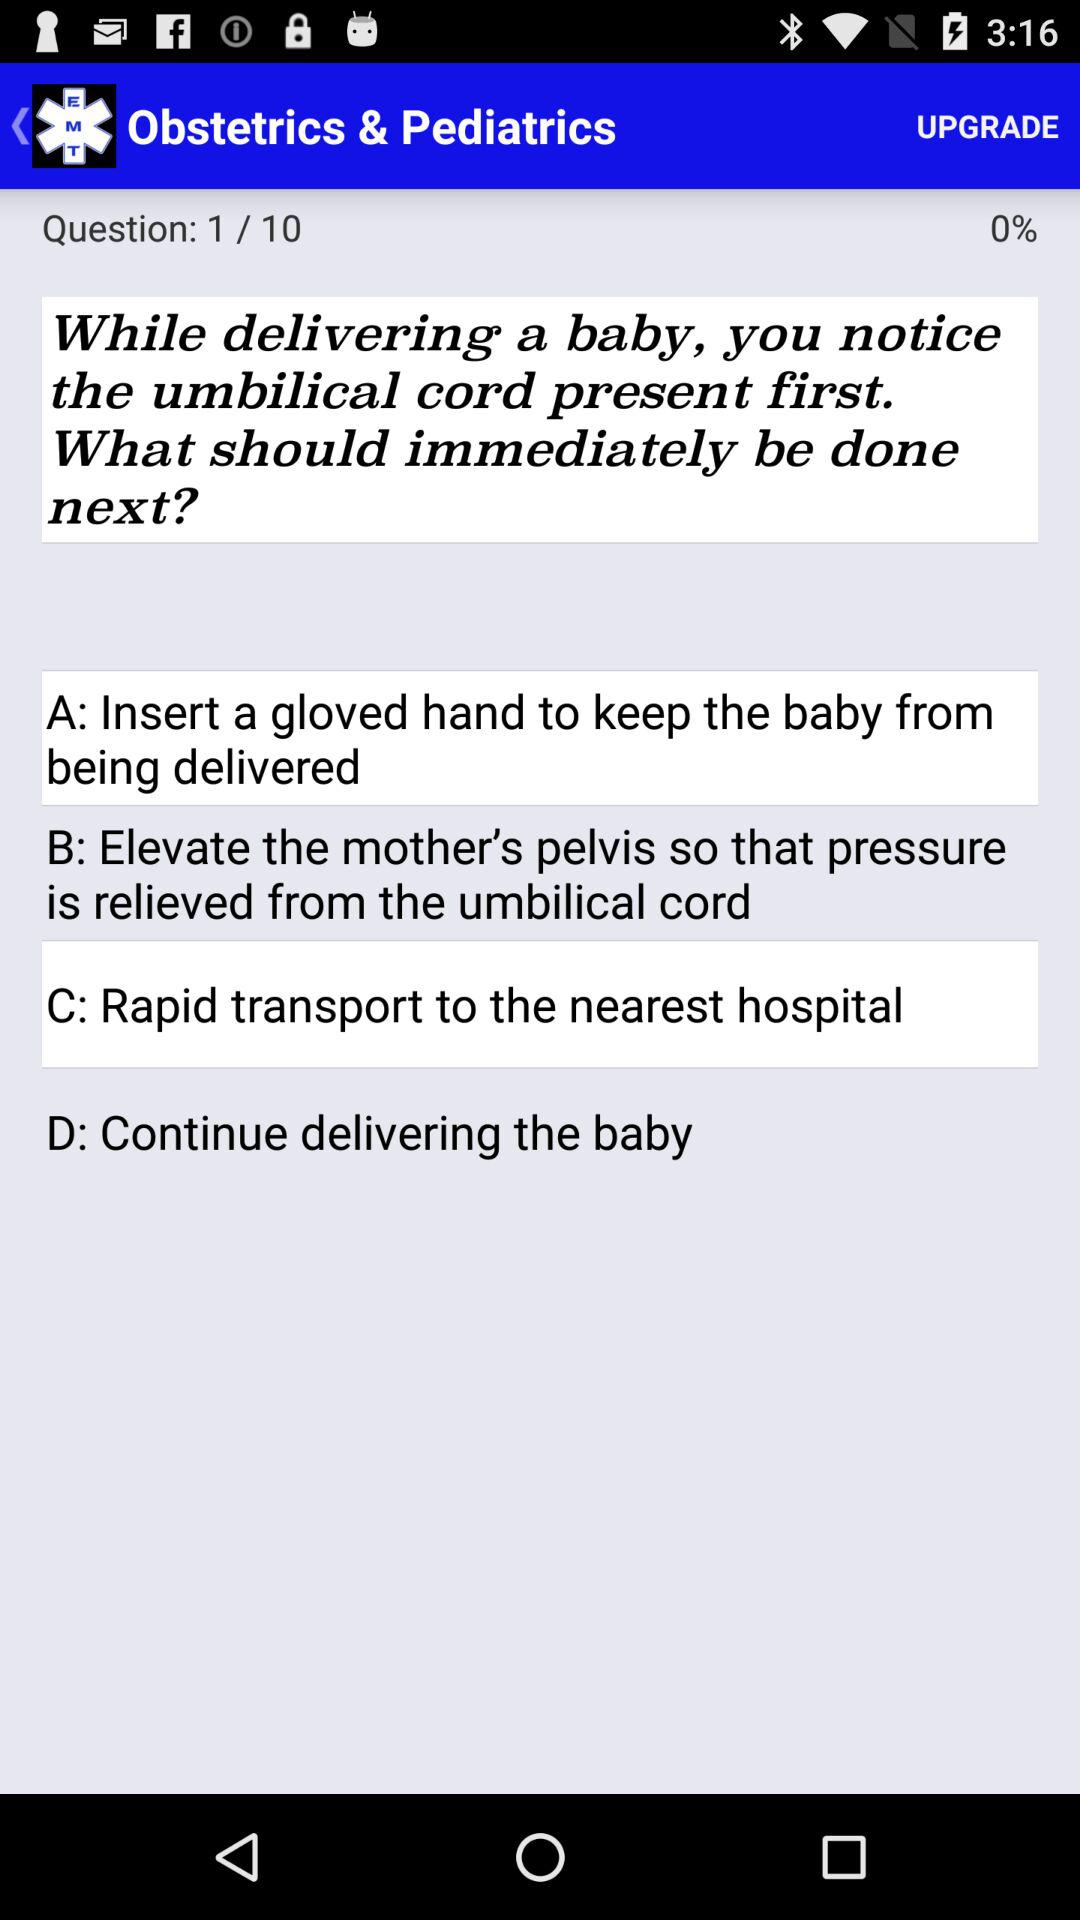How much of a percentage is displayed? The displayed percentage is 0. 